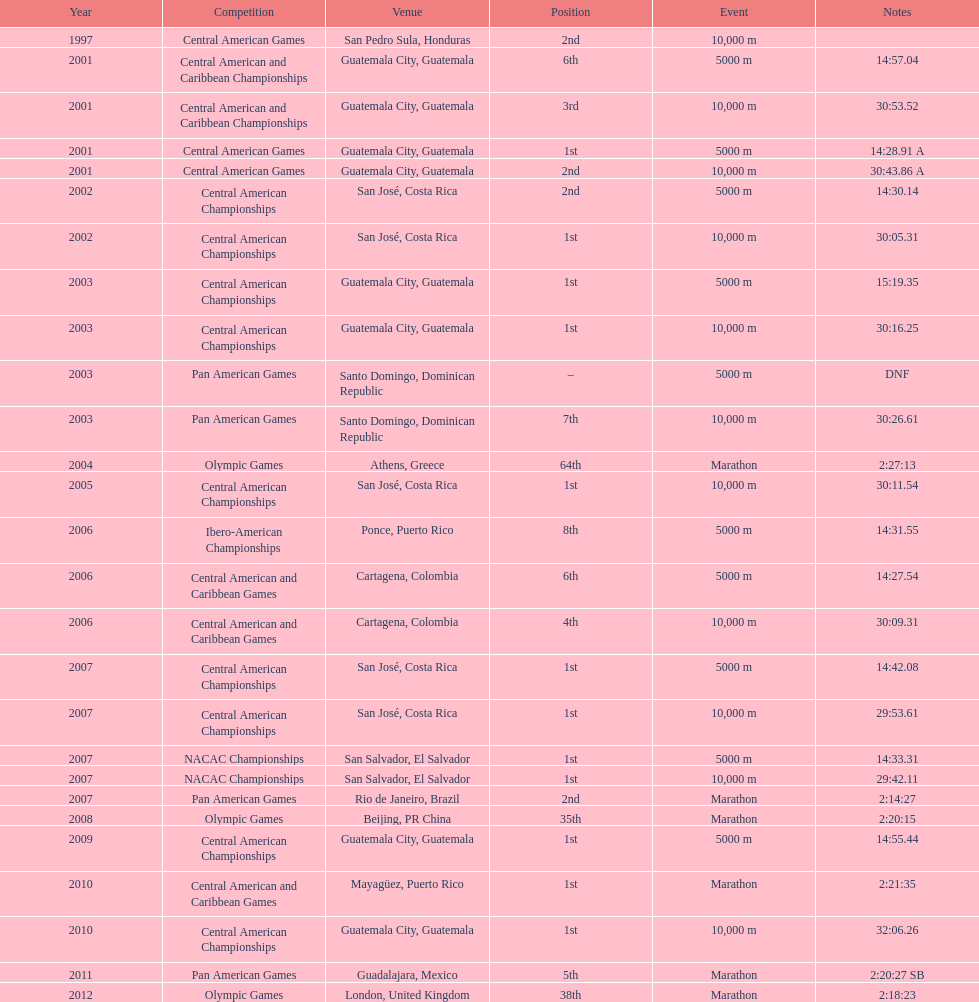How many times has the position of 1st been achieved? 12. 